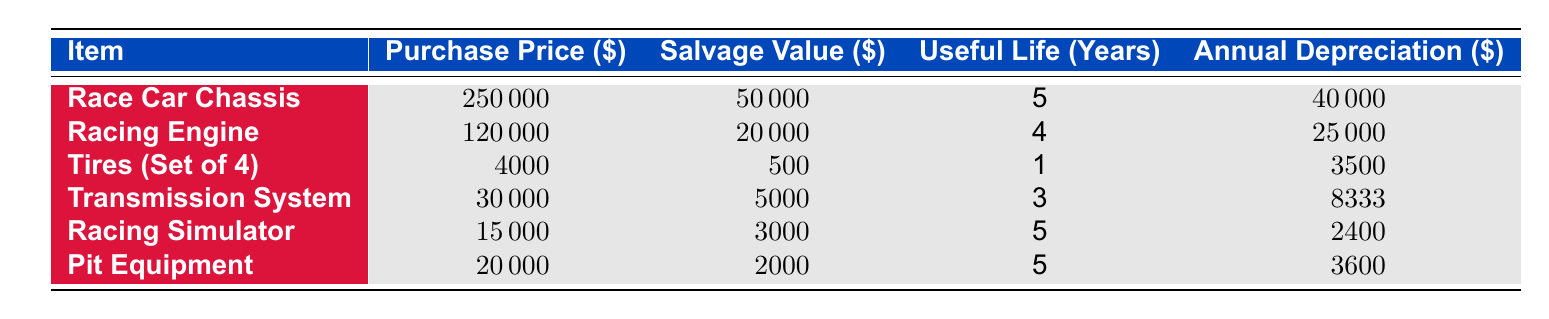What is the purchase price of the Racing Engine? The table lists the Racing Engine under the "Item" column, showing its purchase price in the corresponding column. The value is 120000.
Answer: 120000 What is the salvage value of the Race Car Chassis? Looking at the table, the Race Car Chassis has a listed salvage value of 50000 in the associated column.
Answer: 50000 Which item has the shortest useful life? The table indicates that the Tires (Set of 4) have a useful life of 1 year, which is the lowest value compared to all other items listed.
Answer: Tires (Set of 4) What is the total annual depreciation for all items? To find the total annual depreciation, sum the annual depreciation values: 40000 + 25000 + 3500 + 8333 + 2400 + 3600 = 90633.
Answer: 90633 Does the Pit Equipment have a higher purchase price than the Racing Simulator? Comparing the two, Pit Equipment has a purchase price of 20000 while the Racing Simulator has a purchase price of 15000. Since 20000 is greater than 15000, the statement is true.
Answer: Yes What is the average annual depreciation of the equipment? To find the average, sum the annual depreciation values (40000 + 25000 + 3500 + 8333 + 2400 + 3600 = 90633) and divide by the total number of items (6). So, 90633 / 6 = 15105.5.
Answer: 15105.5 Is the annual depreciation for the Transmission System more than 8000? Looking at the annual depreciation for the Transmission System, which is 8333, we see that it is indeed greater than 8000. Therefore, the statement is true.
Answer: Yes What is the difference in annual depreciation between the Racing Engine and the Race Car Chassis? The annual depreciation for the Racing Engine is 25000 and for the Race Car Chassis is 40000. The difference is calculated as 40000 - 25000 = 15000.
Answer: 15000 Which item has the highest salvage value? By examining the salvage values, the Race Car Chassis has a salvage value of 50000, which is the highest compared to the others.
Answer: Race Car Chassis 